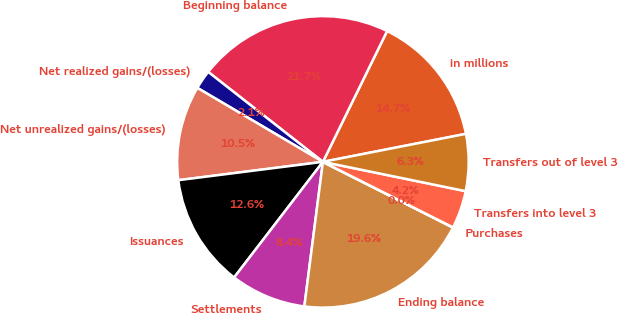Convert chart to OTSL. <chart><loc_0><loc_0><loc_500><loc_500><pie_chart><fcel>in millions<fcel>Beginning balance<fcel>Net realized gains/(losses)<fcel>Net unrealized gains/(losses)<fcel>Issuances<fcel>Settlements<fcel>Ending balance<fcel>Purchases<fcel>Transfers into level 3<fcel>Transfers out of level 3<nl><fcel>14.66%<fcel>21.68%<fcel>2.11%<fcel>10.48%<fcel>12.57%<fcel>8.39%<fcel>19.59%<fcel>0.02%<fcel>4.2%<fcel>6.3%<nl></chart> 